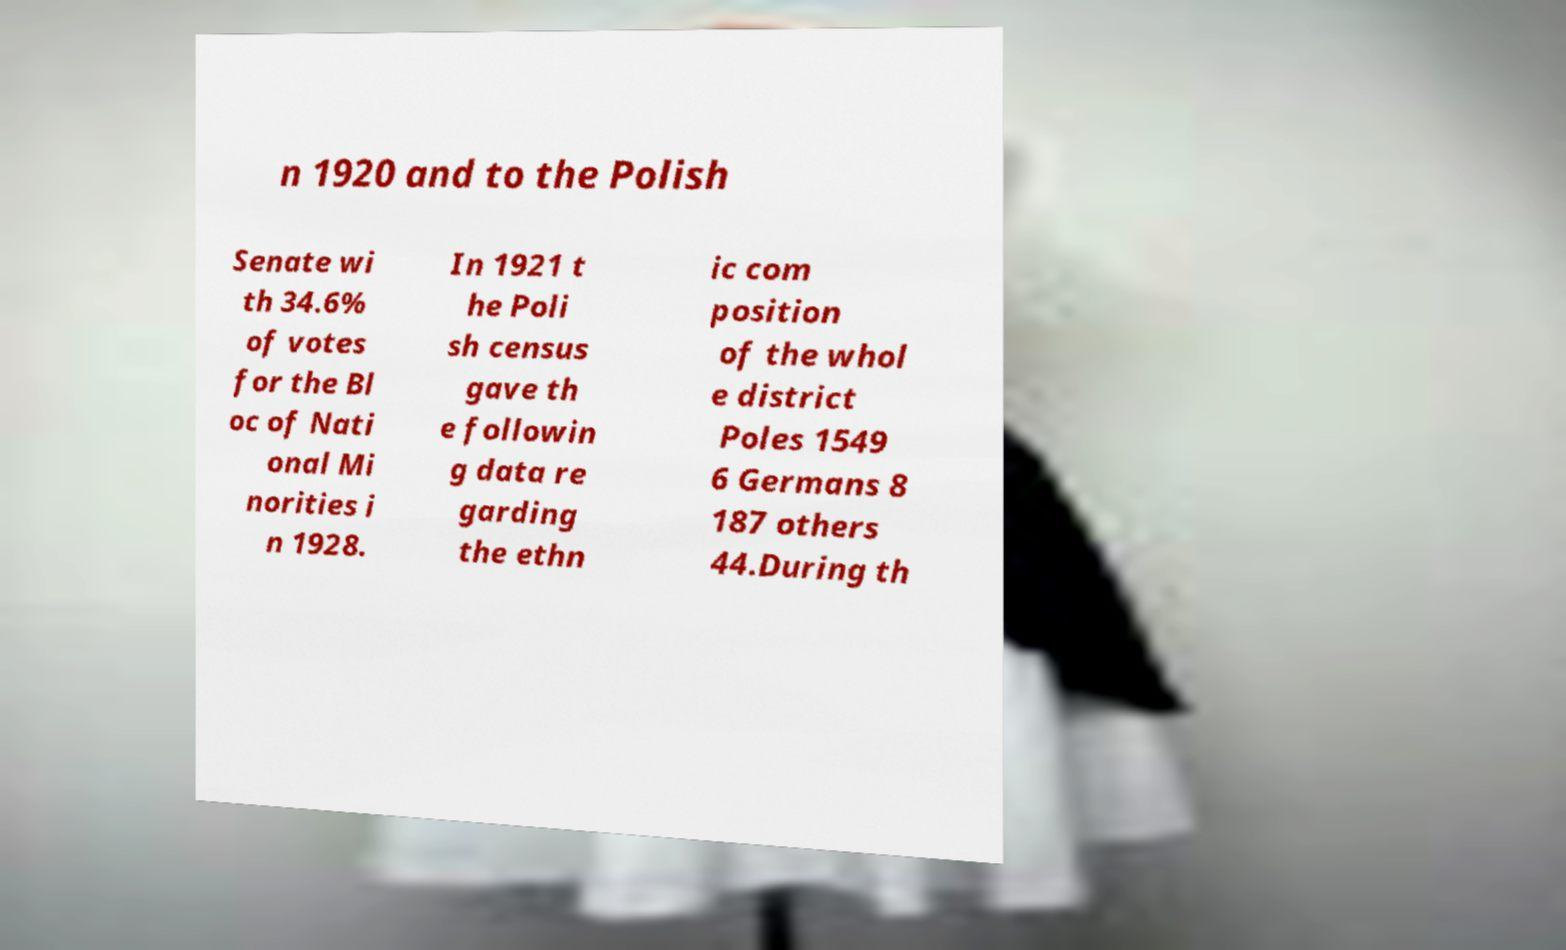Could you extract and type out the text from this image? n 1920 and to the Polish Senate wi th 34.6% of votes for the Bl oc of Nati onal Mi norities i n 1928. In 1921 t he Poli sh census gave th e followin g data re garding the ethn ic com position of the whol e district Poles 1549 6 Germans 8 187 others 44.During th 